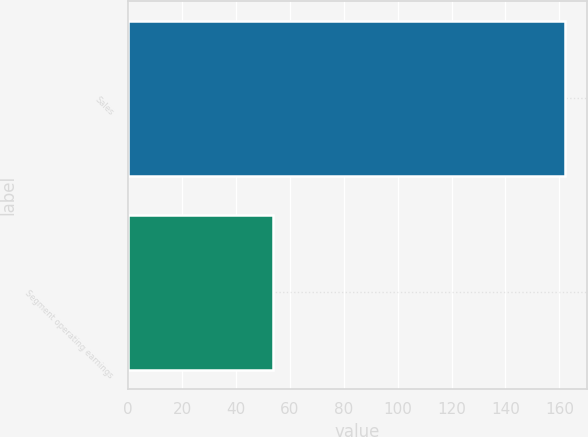<chart> <loc_0><loc_0><loc_500><loc_500><bar_chart><fcel>Sales<fcel>Segment operating earnings<nl><fcel>162.1<fcel>53.8<nl></chart> 